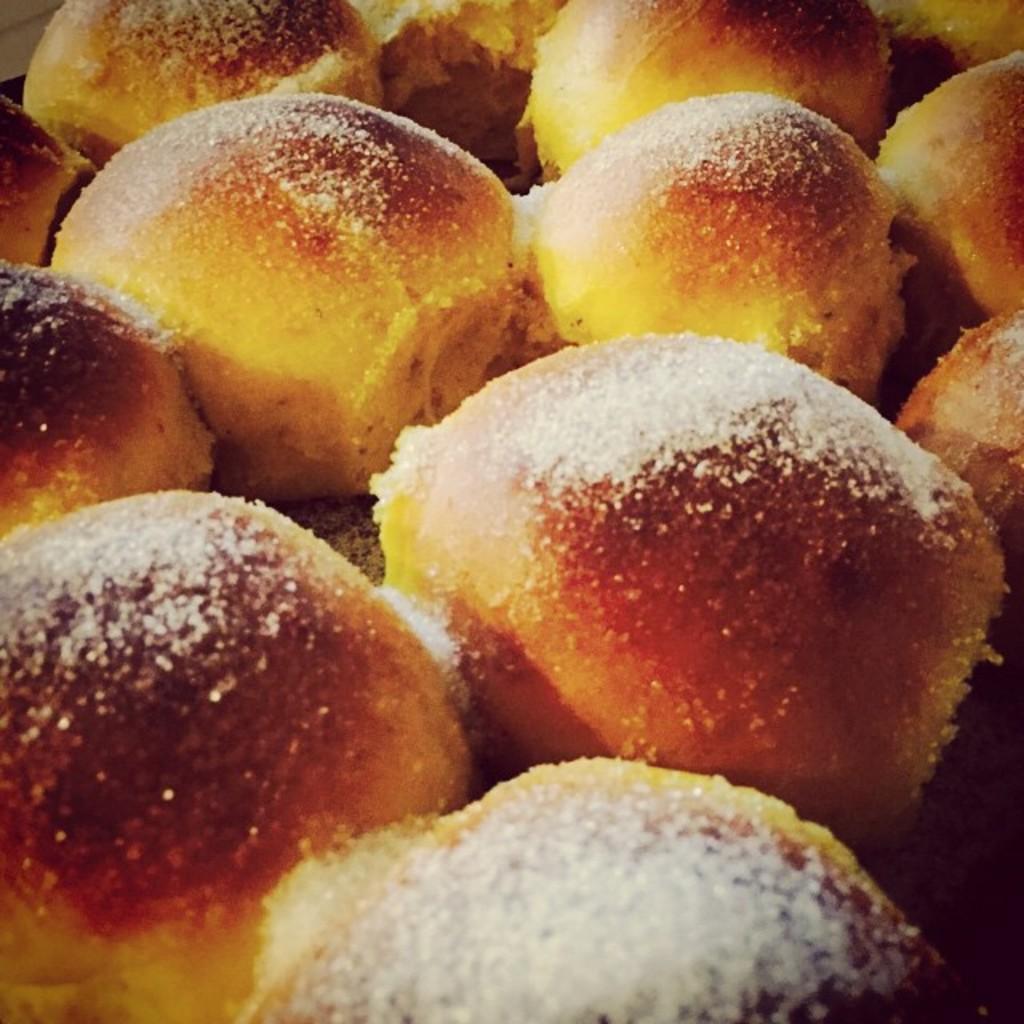Could you give a brief overview of what you see in this image? This image consists of food. It looks like sweets. 